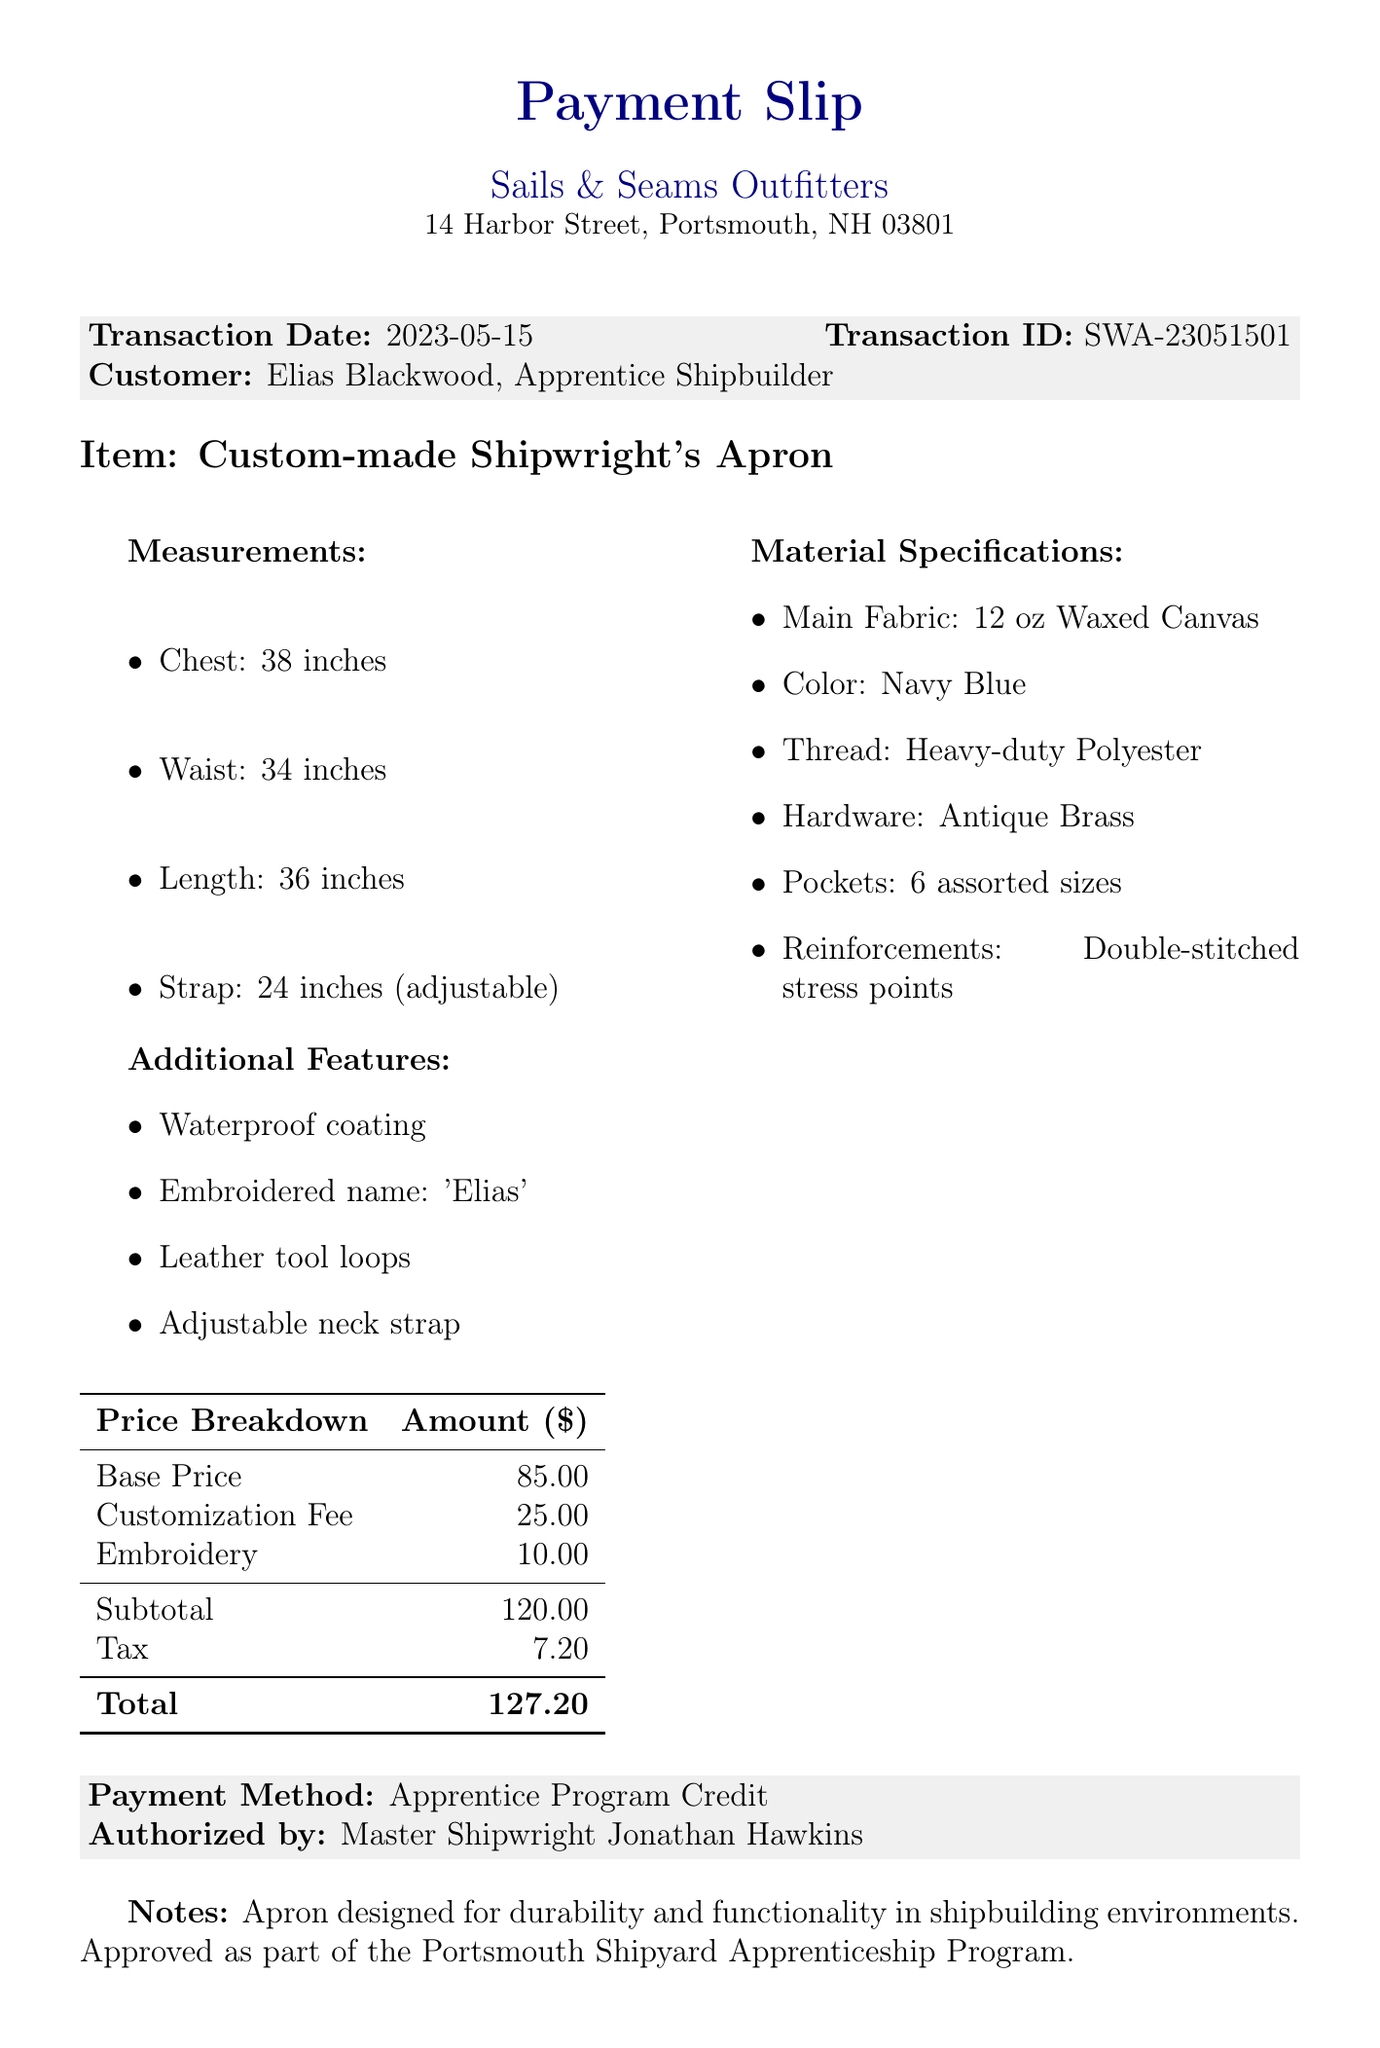What is the transaction date? The transaction date is clearly stated in the document as the date when the payment was made, which is May 15, 2023.
Answer: 2023-05-15 Who is the customer? The document specifies the customer name and their title, which indicates their role, in this case, an apprentice shipbuilder named Elias Blackwood.
Answer: Elias Blackwood What is the total amount due? The total amount due is given at the bottom of the price breakdown as the final total after tax, which sums all previous costs.
Answer: 127.20 What type of fabric is used for the apron? The document provides details about the material specifications, specifically mentioning the type of fabric as 12 oz Waxed Canvas.
Answer: 12 oz Waxed Canvas How many pockets does the apron have? The material specifications include information about pockets, stating that there are a total of six assorted sizes mentioned.
Answer: 6 assorted sizes What is the payment method? The payment method is noted in the document as the financing option or method used to complete the transaction.
Answer: Apprentice Program Credit What additional feature is included with the apron? The document lists several additional features, and one example of an additional feature is mentioned, highlighting its functional aspect.
Answer: Waterproof coating What is the warranty period? The warranty section in the document describes the assurances given for the product, specifically regarding manufacturing defects.
Answer: 90 days What instructions are given for care? The care instructions section details how to properly maintain the apron for longevity, emphasizing a specific washing technique.
Answer: Hand wash in cold water, hang dry, re-wax annually 